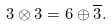Convert formula to latex. <formula><loc_0><loc_0><loc_500><loc_500>3 \otimes 3 = 6 \oplus \overline { 3 } .</formula> 